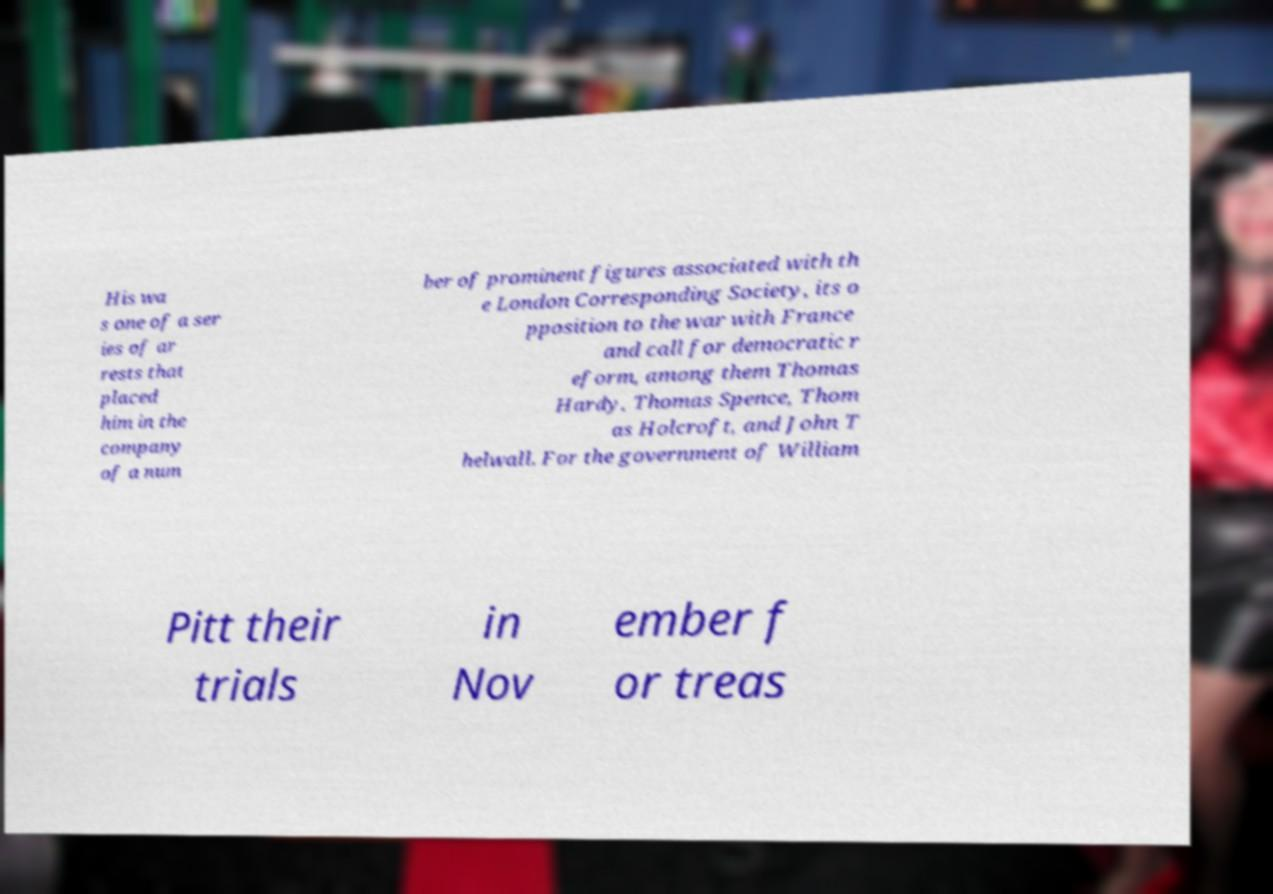What messages or text are displayed in this image? I need them in a readable, typed format. His wa s one of a ser ies of ar rests that placed him in the company of a num ber of prominent figures associated with th e London Corresponding Society, its o pposition to the war with France and call for democratic r eform, among them Thomas Hardy, Thomas Spence, Thom as Holcroft, and John T helwall. For the government of William Pitt their trials in Nov ember f or treas 